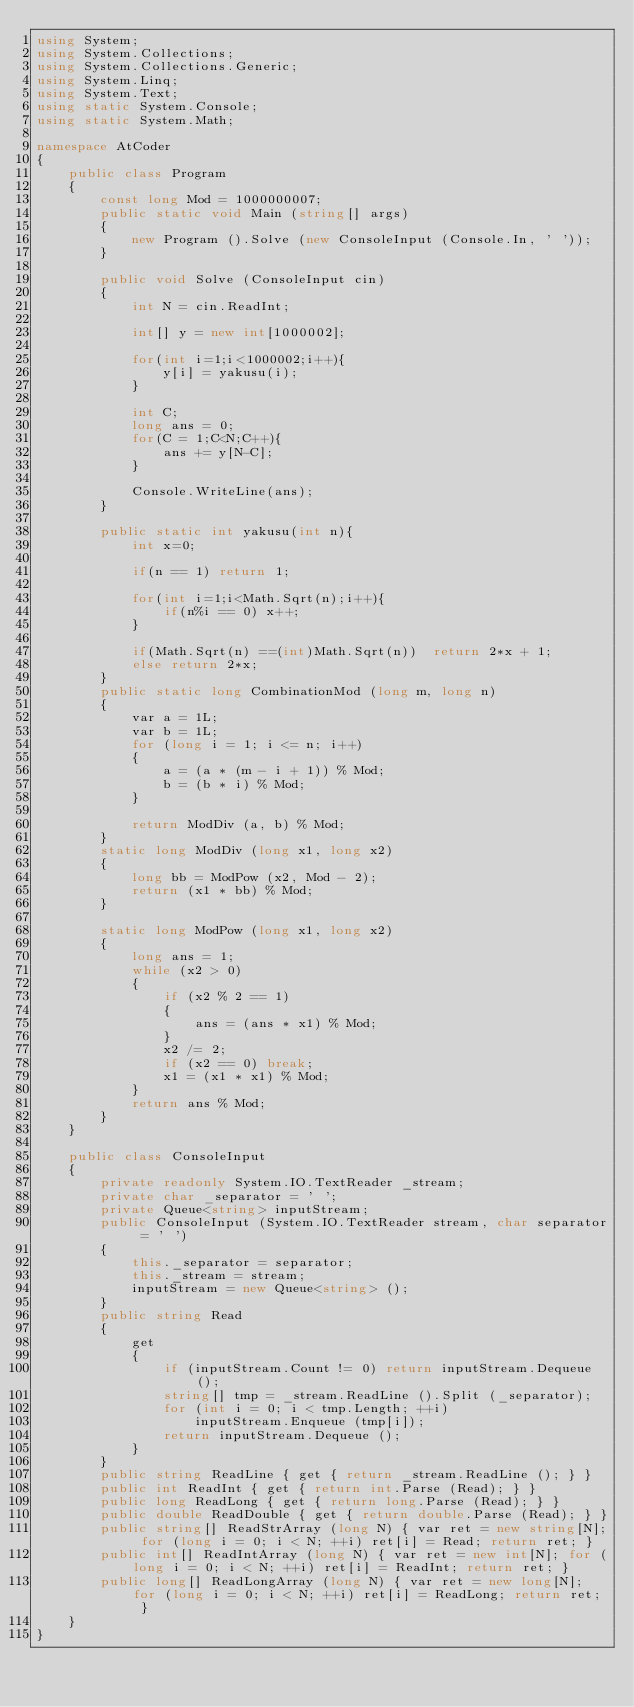<code> <loc_0><loc_0><loc_500><loc_500><_C#_>using System;
using System.Collections;
using System.Collections.Generic;
using System.Linq;
using System.Text;
using static System.Console;
using static System.Math;

namespace AtCoder
{
    public class Program
    {
        const long Mod = 1000000007;
        public static void Main (string[] args)
        {
            new Program ().Solve (new ConsoleInput (Console.In, ' '));
        }

        public void Solve (ConsoleInput cin)
        {
            int N = cin.ReadInt;

            int[] y = new int[1000002];

            for(int i=1;i<1000002;i++){
                y[i] = yakusu(i);
            }

            int C;
            long ans = 0;
            for(C = 1;C<N;C++){
                ans += y[N-C];
            }

            Console.WriteLine(ans);
        }

        public static int yakusu(int n){
            int x=0;

            if(n == 1) return 1;

            for(int i=1;i<Math.Sqrt(n);i++){
                if(n%i == 0) x++;
            }

            if(Math.Sqrt(n) ==(int)Math.Sqrt(n))  return 2*x + 1;
            else return 2*x;
        }
        public static long CombinationMod (long m, long n)
        {
            var a = 1L;
            var b = 1L;
            for (long i = 1; i <= n; i++)
            {
                a = (a * (m - i + 1)) % Mod;
                b = (b * i) % Mod;
            }

            return ModDiv (a, b) % Mod;
        }
        static long ModDiv (long x1, long x2)
        {
            long bb = ModPow (x2, Mod - 2);
            return (x1 * bb) % Mod;
        }

        static long ModPow (long x1, long x2)
        {
            long ans = 1;
            while (x2 > 0)
            {
                if (x2 % 2 == 1)
                {
                    ans = (ans * x1) % Mod;
                }
                x2 /= 2;
                if (x2 == 0) break;
                x1 = (x1 * x1) % Mod;
            }
            return ans % Mod;
        }
    }

    public class ConsoleInput
    {
        private readonly System.IO.TextReader _stream;
        private char _separator = ' ';
        private Queue<string> inputStream;
        public ConsoleInput (System.IO.TextReader stream, char separator = ' ')
        {
            this._separator = separator;
            this._stream = stream;
            inputStream = new Queue<string> ();
        }
        public string Read
        {
            get
            {
                if (inputStream.Count != 0) return inputStream.Dequeue ();
                string[] tmp = _stream.ReadLine ().Split (_separator);
                for (int i = 0; i < tmp.Length; ++i)
                    inputStream.Enqueue (tmp[i]);
                return inputStream.Dequeue ();
            }
        }
        public string ReadLine { get { return _stream.ReadLine (); } }
        public int ReadInt { get { return int.Parse (Read); } }
        public long ReadLong { get { return long.Parse (Read); } }
        public double ReadDouble { get { return double.Parse (Read); } }
        public string[] ReadStrArray (long N) { var ret = new string[N]; for (long i = 0; i < N; ++i) ret[i] = Read; return ret; }
        public int[] ReadIntArray (long N) { var ret = new int[N]; for (long i = 0; i < N; ++i) ret[i] = ReadInt; return ret; }
        public long[] ReadLongArray (long N) { var ret = new long[N]; for (long i = 0; i < N; ++i) ret[i] = ReadLong; return ret; }
    }
}</code> 